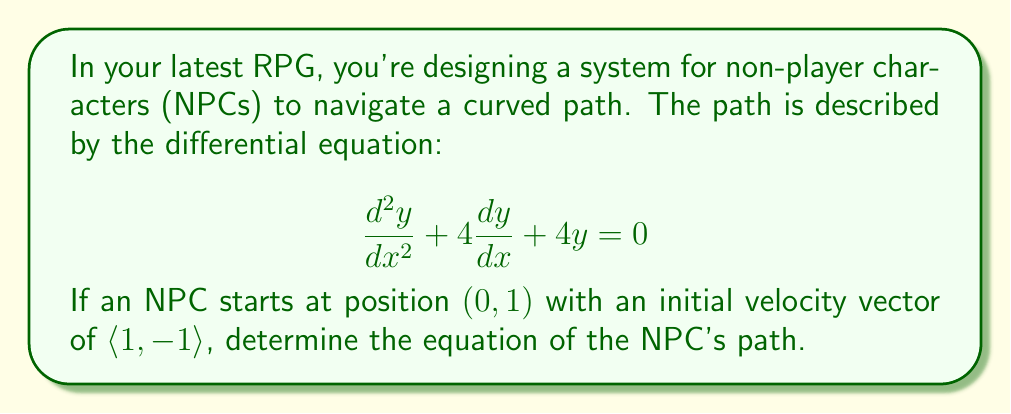Could you help me with this problem? To solve this problem, we need to follow these steps:

1) First, we recognize this as a second-order linear differential equation with constant coefficients. The general solution for such an equation is:

   $$y = c_1e^{r_1x} + c_2e^{r_2x}$$

   where $r_1$ and $r_2$ are roots of the characteristic equation.

2) The characteristic equation is:
   
   $$r^2 + 4r + 4 = 0$$

3) Solving this quadratic equation:
   
   $$r = \frac{-4 \pm \sqrt{16 - 16}}{2} = -2$$

   We have a repeated root, so the general solution takes the form:

   $$y = (c_1 + c_2x)e^{-2x}$$

4) Now we use the initial conditions to find $c_1$ and $c_2$:
   
   At $x=0$, $y=1$: This gives us $c_1 = 1$

   For the initial velocity, we need $\frac{dy}{dx}$ at $x=0$:
   
   $$\frac{dy}{dx} = (-2c_1 - 2c_2x + c_2)e^{-2x}$$
   
   At $x=0$, $\frac{dy}{dx} = -1$: This gives us $-2c_1 + c_2 = -1$

5) Substituting $c_1 = 1$:
   
   $$-2 + c_2 = -1$$
   $$c_2 = 1$$

6) Therefore, the particular solution is:

   $$y = (1 + x)e^{-2x}$$

This equation describes the optimal path for the NPC in your game world.
Answer: $$y = (1 + x)e^{-2x}$$ 